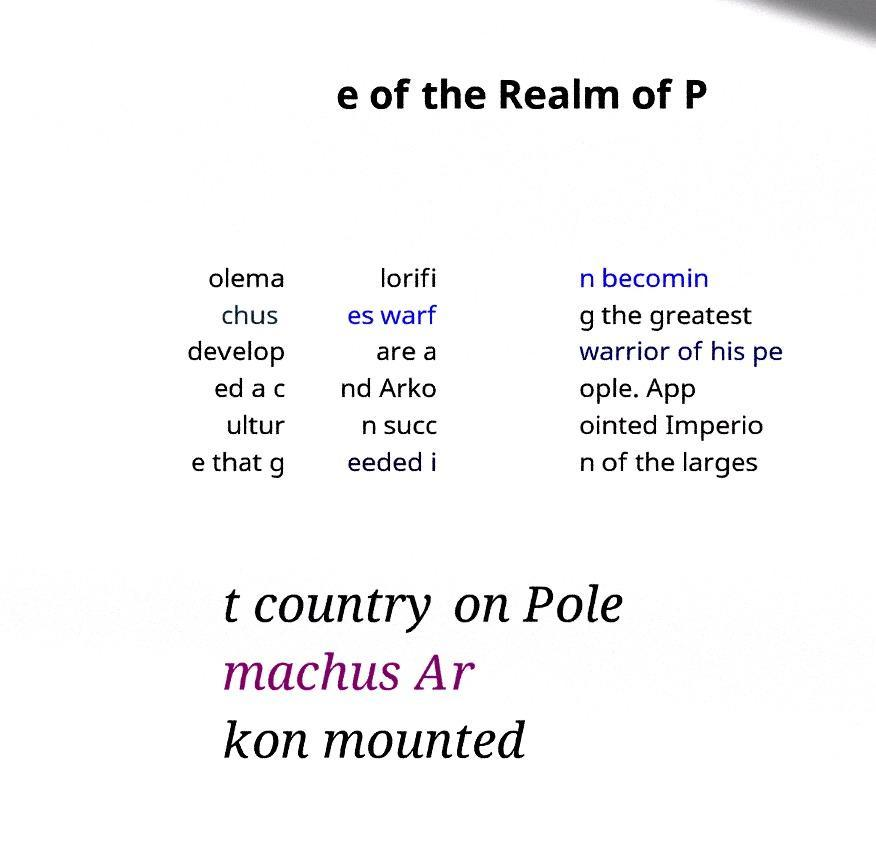For documentation purposes, I need the text within this image transcribed. Could you provide that? e of the Realm of P olema chus develop ed a c ultur e that g lorifi es warf are a nd Arko n succ eeded i n becomin g the greatest warrior of his pe ople. App ointed Imperio n of the larges t country on Pole machus Ar kon mounted 